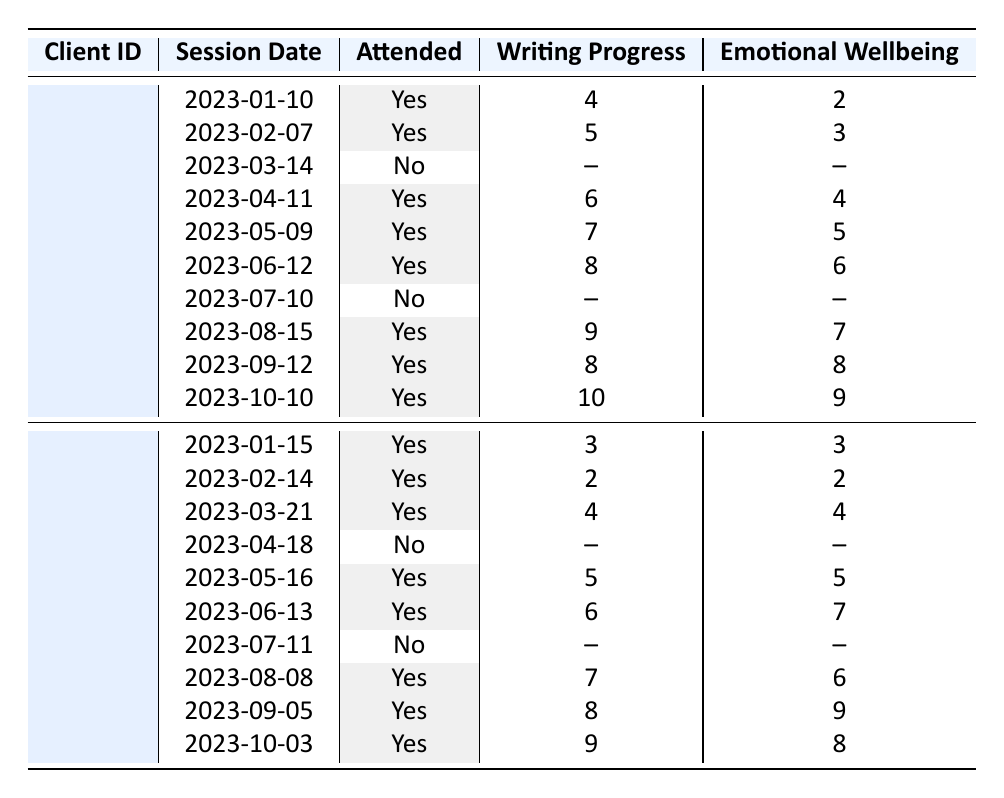What is the total number of sessions attended by client C001? Client C001 attended sessions on the following dates: 2023-01-10, 2023-02-07, 2023-04-11, 2023-05-09, 2023-06-12, 2023-08-15, 2023-09-12, and 2023-10-10. This totals to 8 attended sessions.
Answer: 8 What was the writing progress score on the last attended session for client C002? The last attended session for client C002 is on 2023-10-03, where the writing progress score is 9.
Answer: 9 Did client C001 attend the session on March 14, 2023? The attendance status for the session on March 14, 2023, is marked as "No," indicating that client C001 did not attend.
Answer: No What is the average writing progress score for client C002 over the sessions attended? The writing progress scores for attended sessions of client C002 are 3, 2, 4, 5, 6, 7, 8, and 9. The total is 44 (3 + 2 + 4 + 5 + 6 + 7 + 8 + 9). There are 8 sessions, so the average is 44 / 8 = 5.5.
Answer: 5.5 Which client had the highest writing progress score, and what was that score? By comparing the highest writing progress scores of both clients: C001 has a maximum score of 10 (attended on 2023-10-10) and C002 has a maximum score of 9 (attended on 2023-10-03). Therefore, client C001 had the highest score of 10.
Answer: C001, 10 How many sessions did client C002 miss in 2023? Client C002 missed sessions on two specific dates: 2023-04-18 and 2023-07-11. Thus, the total number of missed sessions is 2.
Answer: 2 What was the emotional wellbeing score for the session attended by client C001 on June 12, 2023? The emotional wellbeing score for client C001 during the session on June 12, 2023, is indicated as 6.
Answer: 6 Did the emotional wellbeing scores improve for client C001 in each session attended from January to October? Checking the scores, client C001's emotional wellbeing scores are: 2, 3, 4, 5, 6, 7, 8, 9. All scores progressively increase, demonstrating consistent improvement over each attended session.
Answer: Yes What is the sum of the writing progress scores for sessions attended by client C001? The writing progress scores for client C001's attended sessions are 4, 5, 6, 7, 8, 9, 8, and 10. Their sum is 57 (4 + 5 + 6 + 7 + 8 + 9 + 8 + 10).
Answer: 57 